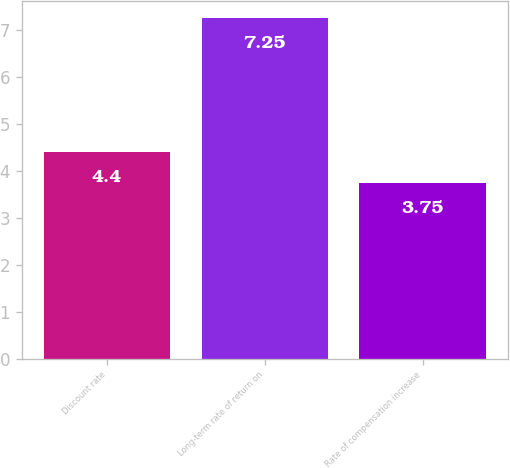Convert chart to OTSL. <chart><loc_0><loc_0><loc_500><loc_500><bar_chart><fcel>Discount rate<fcel>Long-term rate of return on<fcel>Rate of compensation increase<nl><fcel>4.4<fcel>7.25<fcel>3.75<nl></chart> 